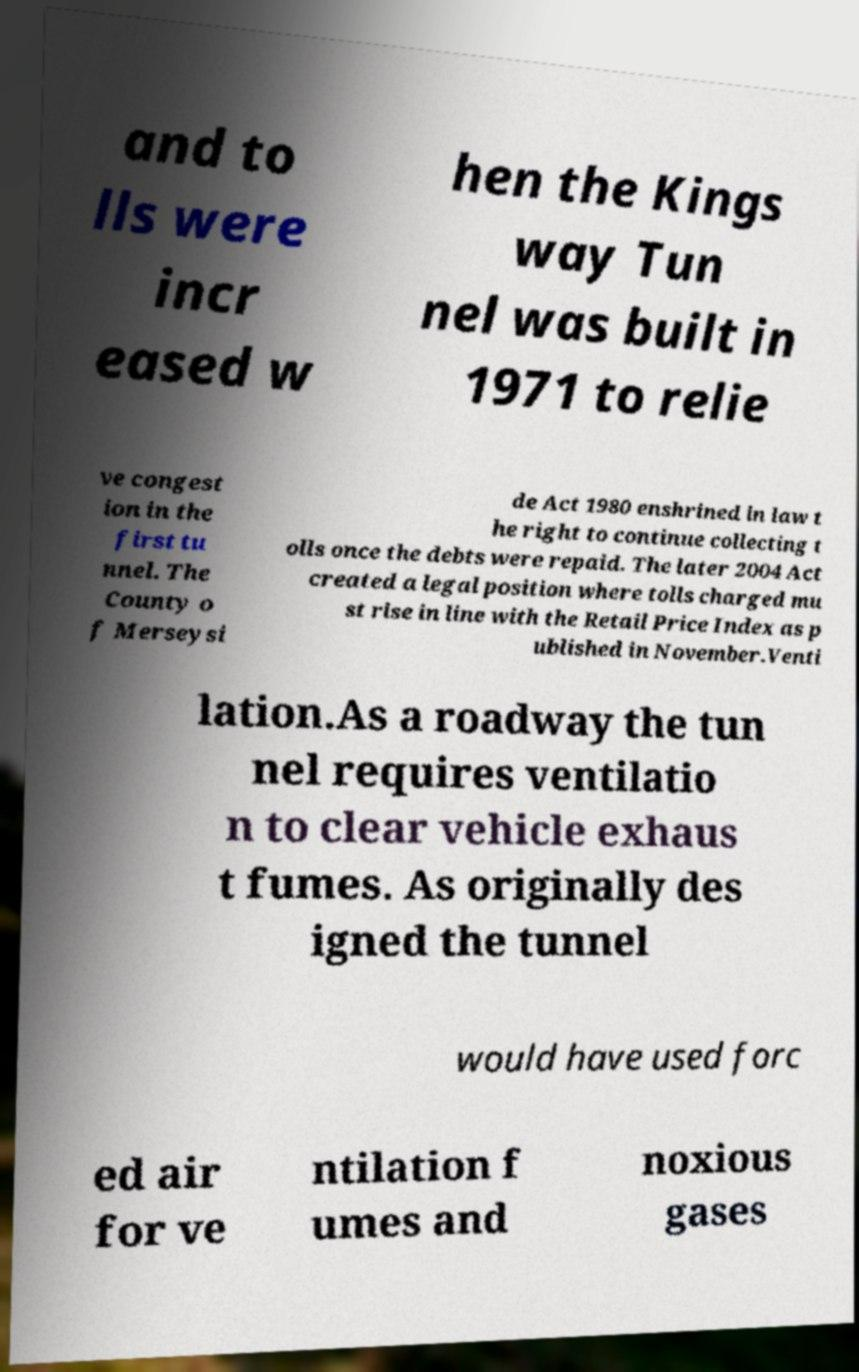Can you accurately transcribe the text from the provided image for me? and to lls were incr eased w hen the Kings way Tun nel was built in 1971 to relie ve congest ion in the first tu nnel. The County o f Merseysi de Act 1980 enshrined in law t he right to continue collecting t olls once the debts were repaid. The later 2004 Act created a legal position where tolls charged mu st rise in line with the Retail Price Index as p ublished in November.Venti lation.As a roadway the tun nel requires ventilatio n to clear vehicle exhaus t fumes. As originally des igned the tunnel would have used forc ed air for ve ntilation f umes and noxious gases 